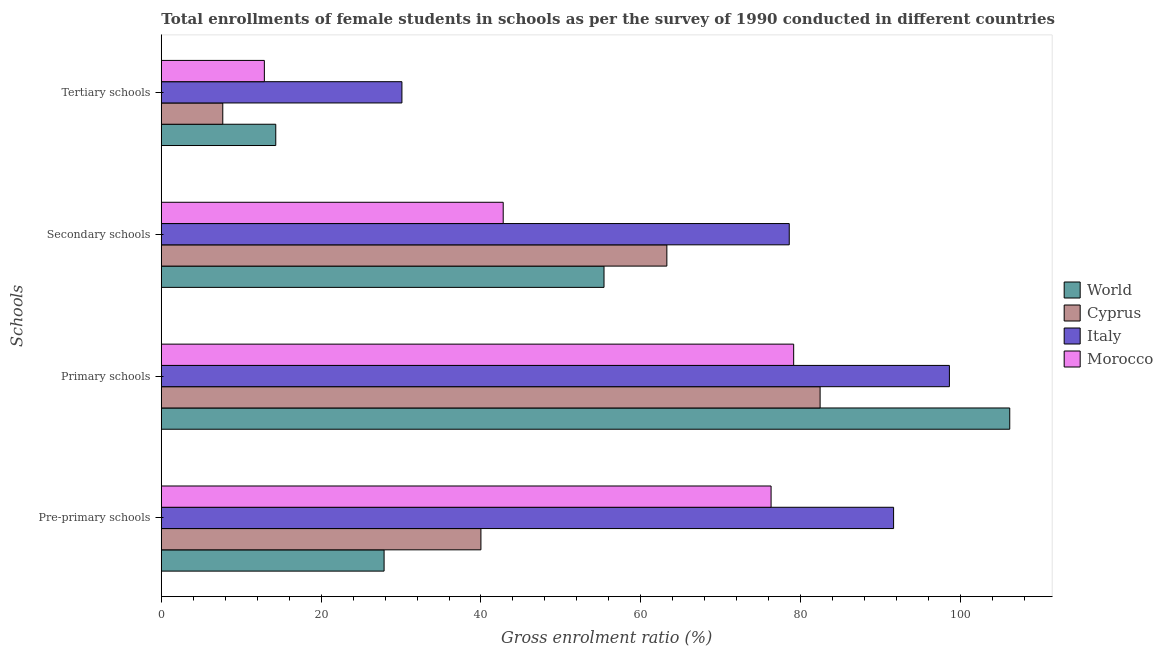How many groups of bars are there?
Offer a terse response. 4. Are the number of bars per tick equal to the number of legend labels?
Provide a short and direct response. Yes. How many bars are there on the 2nd tick from the top?
Offer a very short reply. 4. How many bars are there on the 3rd tick from the bottom?
Give a very brief answer. 4. What is the label of the 1st group of bars from the top?
Provide a short and direct response. Tertiary schools. What is the gross enrolment ratio(female) in pre-primary schools in Italy?
Give a very brief answer. 91.64. Across all countries, what is the maximum gross enrolment ratio(female) in secondary schools?
Provide a short and direct response. 78.58. Across all countries, what is the minimum gross enrolment ratio(female) in pre-primary schools?
Your answer should be very brief. 27.88. In which country was the gross enrolment ratio(female) in pre-primary schools maximum?
Provide a short and direct response. Italy. In which country was the gross enrolment ratio(female) in secondary schools minimum?
Offer a terse response. Morocco. What is the total gross enrolment ratio(female) in primary schools in the graph?
Your response must be concise. 366.37. What is the difference between the gross enrolment ratio(female) in secondary schools in World and that in Cyprus?
Provide a succinct answer. -7.87. What is the difference between the gross enrolment ratio(female) in secondary schools in Morocco and the gross enrolment ratio(female) in primary schools in Italy?
Offer a terse response. -55.84. What is the average gross enrolment ratio(female) in secondary schools per country?
Give a very brief answer. 60.01. What is the difference between the gross enrolment ratio(female) in secondary schools and gross enrolment ratio(female) in tertiary schools in Cyprus?
Provide a succinct answer. 55.57. What is the ratio of the gross enrolment ratio(female) in primary schools in Italy to that in World?
Keep it short and to the point. 0.93. What is the difference between the highest and the second highest gross enrolment ratio(female) in tertiary schools?
Your answer should be compact. 15.79. What is the difference between the highest and the lowest gross enrolment ratio(female) in tertiary schools?
Your response must be concise. 22.42. In how many countries, is the gross enrolment ratio(female) in pre-primary schools greater than the average gross enrolment ratio(female) in pre-primary schools taken over all countries?
Keep it short and to the point. 2. Is the sum of the gross enrolment ratio(female) in secondary schools in Italy and Cyprus greater than the maximum gross enrolment ratio(female) in primary schools across all countries?
Give a very brief answer. Yes. What does the 4th bar from the top in Secondary schools represents?
Your answer should be compact. World. What does the 3rd bar from the bottom in Secondary schools represents?
Your answer should be compact. Italy. How many bars are there?
Offer a very short reply. 16. Are all the bars in the graph horizontal?
Give a very brief answer. Yes. How many countries are there in the graph?
Ensure brevity in your answer.  4. What is the difference between two consecutive major ticks on the X-axis?
Make the answer very short. 20. Does the graph contain any zero values?
Your answer should be compact. No. Does the graph contain grids?
Offer a terse response. No. How many legend labels are there?
Ensure brevity in your answer.  4. What is the title of the graph?
Keep it short and to the point. Total enrollments of female students in schools as per the survey of 1990 conducted in different countries. Does "Cyprus" appear as one of the legend labels in the graph?
Your answer should be very brief. Yes. What is the label or title of the X-axis?
Your response must be concise. Gross enrolment ratio (%). What is the label or title of the Y-axis?
Offer a terse response. Schools. What is the Gross enrolment ratio (%) of World in Pre-primary schools?
Make the answer very short. 27.88. What is the Gross enrolment ratio (%) of Cyprus in Pre-primary schools?
Your answer should be compact. 40. What is the Gross enrolment ratio (%) in Italy in Pre-primary schools?
Make the answer very short. 91.64. What is the Gross enrolment ratio (%) of Morocco in Pre-primary schools?
Provide a succinct answer. 76.31. What is the Gross enrolment ratio (%) in World in Primary schools?
Offer a very short reply. 106.17. What is the Gross enrolment ratio (%) of Cyprus in Primary schools?
Keep it short and to the point. 82.44. What is the Gross enrolment ratio (%) in Italy in Primary schools?
Your answer should be very brief. 98.62. What is the Gross enrolment ratio (%) in Morocco in Primary schools?
Your answer should be compact. 79.13. What is the Gross enrolment ratio (%) of World in Secondary schools?
Your answer should be compact. 55.4. What is the Gross enrolment ratio (%) in Cyprus in Secondary schools?
Your answer should be compact. 63.26. What is the Gross enrolment ratio (%) in Italy in Secondary schools?
Provide a short and direct response. 78.58. What is the Gross enrolment ratio (%) of Morocco in Secondary schools?
Your response must be concise. 42.78. What is the Gross enrolment ratio (%) in World in Tertiary schools?
Offer a very short reply. 14.32. What is the Gross enrolment ratio (%) in Cyprus in Tertiary schools?
Provide a short and direct response. 7.69. What is the Gross enrolment ratio (%) in Italy in Tertiary schools?
Provide a short and direct response. 30.11. What is the Gross enrolment ratio (%) of Morocco in Tertiary schools?
Provide a short and direct response. 12.9. Across all Schools, what is the maximum Gross enrolment ratio (%) in World?
Offer a very short reply. 106.17. Across all Schools, what is the maximum Gross enrolment ratio (%) of Cyprus?
Your answer should be very brief. 82.44. Across all Schools, what is the maximum Gross enrolment ratio (%) of Italy?
Your answer should be very brief. 98.62. Across all Schools, what is the maximum Gross enrolment ratio (%) of Morocco?
Make the answer very short. 79.13. Across all Schools, what is the minimum Gross enrolment ratio (%) of World?
Offer a terse response. 14.32. Across all Schools, what is the minimum Gross enrolment ratio (%) of Cyprus?
Your answer should be compact. 7.69. Across all Schools, what is the minimum Gross enrolment ratio (%) of Italy?
Give a very brief answer. 30.11. Across all Schools, what is the minimum Gross enrolment ratio (%) in Morocco?
Your answer should be compact. 12.9. What is the total Gross enrolment ratio (%) of World in the graph?
Make the answer very short. 203.77. What is the total Gross enrolment ratio (%) of Cyprus in the graph?
Ensure brevity in your answer.  193.39. What is the total Gross enrolment ratio (%) in Italy in the graph?
Keep it short and to the point. 298.95. What is the total Gross enrolment ratio (%) in Morocco in the graph?
Keep it short and to the point. 211.12. What is the difference between the Gross enrolment ratio (%) of World in Pre-primary schools and that in Primary schools?
Your answer should be compact. -78.29. What is the difference between the Gross enrolment ratio (%) in Cyprus in Pre-primary schools and that in Primary schools?
Provide a short and direct response. -42.45. What is the difference between the Gross enrolment ratio (%) of Italy in Pre-primary schools and that in Primary schools?
Provide a short and direct response. -6.98. What is the difference between the Gross enrolment ratio (%) of Morocco in Pre-primary schools and that in Primary schools?
Make the answer very short. -2.83. What is the difference between the Gross enrolment ratio (%) of World in Pre-primary schools and that in Secondary schools?
Make the answer very short. -27.52. What is the difference between the Gross enrolment ratio (%) in Cyprus in Pre-primary schools and that in Secondary schools?
Provide a short and direct response. -23.27. What is the difference between the Gross enrolment ratio (%) of Italy in Pre-primary schools and that in Secondary schools?
Your response must be concise. 13.06. What is the difference between the Gross enrolment ratio (%) in Morocco in Pre-primary schools and that in Secondary schools?
Make the answer very short. 33.52. What is the difference between the Gross enrolment ratio (%) in World in Pre-primary schools and that in Tertiary schools?
Your answer should be very brief. 13.56. What is the difference between the Gross enrolment ratio (%) in Cyprus in Pre-primary schools and that in Tertiary schools?
Keep it short and to the point. 32.3. What is the difference between the Gross enrolment ratio (%) in Italy in Pre-primary schools and that in Tertiary schools?
Give a very brief answer. 61.53. What is the difference between the Gross enrolment ratio (%) in Morocco in Pre-primary schools and that in Tertiary schools?
Your answer should be compact. 63.41. What is the difference between the Gross enrolment ratio (%) in World in Primary schools and that in Secondary schools?
Ensure brevity in your answer.  50.77. What is the difference between the Gross enrolment ratio (%) of Cyprus in Primary schools and that in Secondary schools?
Your response must be concise. 19.18. What is the difference between the Gross enrolment ratio (%) of Italy in Primary schools and that in Secondary schools?
Offer a very short reply. 20.04. What is the difference between the Gross enrolment ratio (%) in Morocco in Primary schools and that in Secondary schools?
Offer a terse response. 36.35. What is the difference between the Gross enrolment ratio (%) of World in Primary schools and that in Tertiary schools?
Provide a succinct answer. 91.85. What is the difference between the Gross enrolment ratio (%) in Cyprus in Primary schools and that in Tertiary schools?
Offer a terse response. 74.75. What is the difference between the Gross enrolment ratio (%) of Italy in Primary schools and that in Tertiary schools?
Ensure brevity in your answer.  68.51. What is the difference between the Gross enrolment ratio (%) of Morocco in Primary schools and that in Tertiary schools?
Provide a short and direct response. 66.24. What is the difference between the Gross enrolment ratio (%) of World in Secondary schools and that in Tertiary schools?
Ensure brevity in your answer.  41.08. What is the difference between the Gross enrolment ratio (%) of Cyprus in Secondary schools and that in Tertiary schools?
Make the answer very short. 55.57. What is the difference between the Gross enrolment ratio (%) in Italy in Secondary schools and that in Tertiary schools?
Provide a short and direct response. 48.47. What is the difference between the Gross enrolment ratio (%) in Morocco in Secondary schools and that in Tertiary schools?
Offer a terse response. 29.89. What is the difference between the Gross enrolment ratio (%) of World in Pre-primary schools and the Gross enrolment ratio (%) of Cyprus in Primary schools?
Ensure brevity in your answer.  -54.56. What is the difference between the Gross enrolment ratio (%) in World in Pre-primary schools and the Gross enrolment ratio (%) in Italy in Primary schools?
Your answer should be very brief. -70.74. What is the difference between the Gross enrolment ratio (%) in World in Pre-primary schools and the Gross enrolment ratio (%) in Morocco in Primary schools?
Make the answer very short. -51.25. What is the difference between the Gross enrolment ratio (%) of Cyprus in Pre-primary schools and the Gross enrolment ratio (%) of Italy in Primary schools?
Your answer should be compact. -58.62. What is the difference between the Gross enrolment ratio (%) in Cyprus in Pre-primary schools and the Gross enrolment ratio (%) in Morocco in Primary schools?
Your answer should be compact. -39.14. What is the difference between the Gross enrolment ratio (%) of Italy in Pre-primary schools and the Gross enrolment ratio (%) of Morocco in Primary schools?
Offer a very short reply. 12.5. What is the difference between the Gross enrolment ratio (%) in World in Pre-primary schools and the Gross enrolment ratio (%) in Cyprus in Secondary schools?
Provide a short and direct response. -35.39. What is the difference between the Gross enrolment ratio (%) in World in Pre-primary schools and the Gross enrolment ratio (%) in Italy in Secondary schools?
Give a very brief answer. -50.7. What is the difference between the Gross enrolment ratio (%) of World in Pre-primary schools and the Gross enrolment ratio (%) of Morocco in Secondary schools?
Your response must be concise. -14.9. What is the difference between the Gross enrolment ratio (%) of Cyprus in Pre-primary schools and the Gross enrolment ratio (%) of Italy in Secondary schools?
Provide a succinct answer. -38.58. What is the difference between the Gross enrolment ratio (%) in Cyprus in Pre-primary schools and the Gross enrolment ratio (%) in Morocco in Secondary schools?
Provide a short and direct response. -2.79. What is the difference between the Gross enrolment ratio (%) of Italy in Pre-primary schools and the Gross enrolment ratio (%) of Morocco in Secondary schools?
Your response must be concise. 48.85. What is the difference between the Gross enrolment ratio (%) in World in Pre-primary schools and the Gross enrolment ratio (%) in Cyprus in Tertiary schools?
Ensure brevity in your answer.  20.19. What is the difference between the Gross enrolment ratio (%) of World in Pre-primary schools and the Gross enrolment ratio (%) of Italy in Tertiary schools?
Offer a very short reply. -2.23. What is the difference between the Gross enrolment ratio (%) in World in Pre-primary schools and the Gross enrolment ratio (%) in Morocco in Tertiary schools?
Offer a terse response. 14.98. What is the difference between the Gross enrolment ratio (%) of Cyprus in Pre-primary schools and the Gross enrolment ratio (%) of Italy in Tertiary schools?
Ensure brevity in your answer.  9.89. What is the difference between the Gross enrolment ratio (%) of Cyprus in Pre-primary schools and the Gross enrolment ratio (%) of Morocco in Tertiary schools?
Your answer should be compact. 27.1. What is the difference between the Gross enrolment ratio (%) of Italy in Pre-primary schools and the Gross enrolment ratio (%) of Morocco in Tertiary schools?
Provide a short and direct response. 78.74. What is the difference between the Gross enrolment ratio (%) in World in Primary schools and the Gross enrolment ratio (%) in Cyprus in Secondary schools?
Your response must be concise. 42.91. What is the difference between the Gross enrolment ratio (%) in World in Primary schools and the Gross enrolment ratio (%) in Italy in Secondary schools?
Offer a terse response. 27.59. What is the difference between the Gross enrolment ratio (%) of World in Primary schools and the Gross enrolment ratio (%) of Morocco in Secondary schools?
Offer a terse response. 63.39. What is the difference between the Gross enrolment ratio (%) in Cyprus in Primary schools and the Gross enrolment ratio (%) in Italy in Secondary schools?
Keep it short and to the point. 3.86. What is the difference between the Gross enrolment ratio (%) in Cyprus in Primary schools and the Gross enrolment ratio (%) in Morocco in Secondary schools?
Your answer should be very brief. 39.66. What is the difference between the Gross enrolment ratio (%) in Italy in Primary schools and the Gross enrolment ratio (%) in Morocco in Secondary schools?
Provide a short and direct response. 55.84. What is the difference between the Gross enrolment ratio (%) of World in Primary schools and the Gross enrolment ratio (%) of Cyprus in Tertiary schools?
Provide a short and direct response. 98.48. What is the difference between the Gross enrolment ratio (%) in World in Primary schools and the Gross enrolment ratio (%) in Italy in Tertiary schools?
Provide a short and direct response. 76.06. What is the difference between the Gross enrolment ratio (%) in World in Primary schools and the Gross enrolment ratio (%) in Morocco in Tertiary schools?
Offer a terse response. 93.28. What is the difference between the Gross enrolment ratio (%) of Cyprus in Primary schools and the Gross enrolment ratio (%) of Italy in Tertiary schools?
Your response must be concise. 52.33. What is the difference between the Gross enrolment ratio (%) of Cyprus in Primary schools and the Gross enrolment ratio (%) of Morocco in Tertiary schools?
Give a very brief answer. 69.55. What is the difference between the Gross enrolment ratio (%) of Italy in Primary schools and the Gross enrolment ratio (%) of Morocco in Tertiary schools?
Your answer should be compact. 85.73. What is the difference between the Gross enrolment ratio (%) of World in Secondary schools and the Gross enrolment ratio (%) of Cyprus in Tertiary schools?
Your answer should be very brief. 47.71. What is the difference between the Gross enrolment ratio (%) of World in Secondary schools and the Gross enrolment ratio (%) of Italy in Tertiary schools?
Your answer should be compact. 25.29. What is the difference between the Gross enrolment ratio (%) in World in Secondary schools and the Gross enrolment ratio (%) in Morocco in Tertiary schools?
Ensure brevity in your answer.  42.5. What is the difference between the Gross enrolment ratio (%) of Cyprus in Secondary schools and the Gross enrolment ratio (%) of Italy in Tertiary schools?
Offer a very short reply. 33.15. What is the difference between the Gross enrolment ratio (%) in Cyprus in Secondary schools and the Gross enrolment ratio (%) in Morocco in Tertiary schools?
Offer a very short reply. 50.37. What is the difference between the Gross enrolment ratio (%) of Italy in Secondary schools and the Gross enrolment ratio (%) of Morocco in Tertiary schools?
Ensure brevity in your answer.  65.68. What is the average Gross enrolment ratio (%) of World per Schools?
Make the answer very short. 50.94. What is the average Gross enrolment ratio (%) of Cyprus per Schools?
Give a very brief answer. 48.35. What is the average Gross enrolment ratio (%) of Italy per Schools?
Ensure brevity in your answer.  74.74. What is the average Gross enrolment ratio (%) of Morocco per Schools?
Give a very brief answer. 52.78. What is the difference between the Gross enrolment ratio (%) of World and Gross enrolment ratio (%) of Cyprus in Pre-primary schools?
Give a very brief answer. -12.12. What is the difference between the Gross enrolment ratio (%) in World and Gross enrolment ratio (%) in Italy in Pre-primary schools?
Give a very brief answer. -63.76. What is the difference between the Gross enrolment ratio (%) in World and Gross enrolment ratio (%) in Morocco in Pre-primary schools?
Offer a very short reply. -48.43. What is the difference between the Gross enrolment ratio (%) in Cyprus and Gross enrolment ratio (%) in Italy in Pre-primary schools?
Provide a short and direct response. -51.64. What is the difference between the Gross enrolment ratio (%) in Cyprus and Gross enrolment ratio (%) in Morocco in Pre-primary schools?
Provide a succinct answer. -36.31. What is the difference between the Gross enrolment ratio (%) in Italy and Gross enrolment ratio (%) in Morocco in Pre-primary schools?
Offer a very short reply. 15.33. What is the difference between the Gross enrolment ratio (%) in World and Gross enrolment ratio (%) in Cyprus in Primary schools?
Your response must be concise. 23.73. What is the difference between the Gross enrolment ratio (%) in World and Gross enrolment ratio (%) in Italy in Primary schools?
Offer a terse response. 7.55. What is the difference between the Gross enrolment ratio (%) of World and Gross enrolment ratio (%) of Morocco in Primary schools?
Provide a short and direct response. 27.04. What is the difference between the Gross enrolment ratio (%) in Cyprus and Gross enrolment ratio (%) in Italy in Primary schools?
Your answer should be very brief. -16.18. What is the difference between the Gross enrolment ratio (%) in Cyprus and Gross enrolment ratio (%) in Morocco in Primary schools?
Your response must be concise. 3.31. What is the difference between the Gross enrolment ratio (%) in Italy and Gross enrolment ratio (%) in Morocco in Primary schools?
Your answer should be compact. 19.49. What is the difference between the Gross enrolment ratio (%) of World and Gross enrolment ratio (%) of Cyprus in Secondary schools?
Your response must be concise. -7.87. What is the difference between the Gross enrolment ratio (%) in World and Gross enrolment ratio (%) in Italy in Secondary schools?
Your answer should be compact. -23.18. What is the difference between the Gross enrolment ratio (%) in World and Gross enrolment ratio (%) in Morocco in Secondary schools?
Your response must be concise. 12.62. What is the difference between the Gross enrolment ratio (%) of Cyprus and Gross enrolment ratio (%) of Italy in Secondary schools?
Your response must be concise. -15.32. What is the difference between the Gross enrolment ratio (%) in Cyprus and Gross enrolment ratio (%) in Morocco in Secondary schools?
Offer a terse response. 20.48. What is the difference between the Gross enrolment ratio (%) in Italy and Gross enrolment ratio (%) in Morocco in Secondary schools?
Ensure brevity in your answer.  35.8. What is the difference between the Gross enrolment ratio (%) of World and Gross enrolment ratio (%) of Cyprus in Tertiary schools?
Give a very brief answer. 6.63. What is the difference between the Gross enrolment ratio (%) of World and Gross enrolment ratio (%) of Italy in Tertiary schools?
Provide a succinct answer. -15.79. What is the difference between the Gross enrolment ratio (%) in World and Gross enrolment ratio (%) in Morocco in Tertiary schools?
Your response must be concise. 1.43. What is the difference between the Gross enrolment ratio (%) in Cyprus and Gross enrolment ratio (%) in Italy in Tertiary schools?
Your answer should be compact. -22.42. What is the difference between the Gross enrolment ratio (%) of Cyprus and Gross enrolment ratio (%) of Morocco in Tertiary schools?
Provide a succinct answer. -5.2. What is the difference between the Gross enrolment ratio (%) in Italy and Gross enrolment ratio (%) in Morocco in Tertiary schools?
Provide a succinct answer. 17.21. What is the ratio of the Gross enrolment ratio (%) in World in Pre-primary schools to that in Primary schools?
Offer a very short reply. 0.26. What is the ratio of the Gross enrolment ratio (%) in Cyprus in Pre-primary schools to that in Primary schools?
Your answer should be compact. 0.49. What is the ratio of the Gross enrolment ratio (%) in Italy in Pre-primary schools to that in Primary schools?
Ensure brevity in your answer.  0.93. What is the ratio of the Gross enrolment ratio (%) of Morocco in Pre-primary schools to that in Primary schools?
Make the answer very short. 0.96. What is the ratio of the Gross enrolment ratio (%) in World in Pre-primary schools to that in Secondary schools?
Provide a short and direct response. 0.5. What is the ratio of the Gross enrolment ratio (%) of Cyprus in Pre-primary schools to that in Secondary schools?
Ensure brevity in your answer.  0.63. What is the ratio of the Gross enrolment ratio (%) of Italy in Pre-primary schools to that in Secondary schools?
Offer a very short reply. 1.17. What is the ratio of the Gross enrolment ratio (%) of Morocco in Pre-primary schools to that in Secondary schools?
Keep it short and to the point. 1.78. What is the ratio of the Gross enrolment ratio (%) in World in Pre-primary schools to that in Tertiary schools?
Make the answer very short. 1.95. What is the ratio of the Gross enrolment ratio (%) in Cyprus in Pre-primary schools to that in Tertiary schools?
Offer a terse response. 5.2. What is the ratio of the Gross enrolment ratio (%) of Italy in Pre-primary schools to that in Tertiary schools?
Your answer should be very brief. 3.04. What is the ratio of the Gross enrolment ratio (%) of Morocco in Pre-primary schools to that in Tertiary schools?
Keep it short and to the point. 5.92. What is the ratio of the Gross enrolment ratio (%) of World in Primary schools to that in Secondary schools?
Give a very brief answer. 1.92. What is the ratio of the Gross enrolment ratio (%) of Cyprus in Primary schools to that in Secondary schools?
Keep it short and to the point. 1.3. What is the ratio of the Gross enrolment ratio (%) of Italy in Primary schools to that in Secondary schools?
Ensure brevity in your answer.  1.25. What is the ratio of the Gross enrolment ratio (%) in Morocco in Primary schools to that in Secondary schools?
Your response must be concise. 1.85. What is the ratio of the Gross enrolment ratio (%) in World in Primary schools to that in Tertiary schools?
Provide a short and direct response. 7.41. What is the ratio of the Gross enrolment ratio (%) in Cyprus in Primary schools to that in Tertiary schools?
Make the answer very short. 10.72. What is the ratio of the Gross enrolment ratio (%) in Italy in Primary schools to that in Tertiary schools?
Make the answer very short. 3.28. What is the ratio of the Gross enrolment ratio (%) of Morocco in Primary schools to that in Tertiary schools?
Your answer should be very brief. 6.14. What is the ratio of the Gross enrolment ratio (%) of World in Secondary schools to that in Tertiary schools?
Offer a very short reply. 3.87. What is the ratio of the Gross enrolment ratio (%) of Cyprus in Secondary schools to that in Tertiary schools?
Give a very brief answer. 8.22. What is the ratio of the Gross enrolment ratio (%) of Italy in Secondary schools to that in Tertiary schools?
Your answer should be compact. 2.61. What is the ratio of the Gross enrolment ratio (%) of Morocco in Secondary schools to that in Tertiary schools?
Offer a very short reply. 3.32. What is the difference between the highest and the second highest Gross enrolment ratio (%) of World?
Make the answer very short. 50.77. What is the difference between the highest and the second highest Gross enrolment ratio (%) in Cyprus?
Offer a terse response. 19.18. What is the difference between the highest and the second highest Gross enrolment ratio (%) in Italy?
Your answer should be very brief. 6.98. What is the difference between the highest and the second highest Gross enrolment ratio (%) in Morocco?
Ensure brevity in your answer.  2.83. What is the difference between the highest and the lowest Gross enrolment ratio (%) of World?
Ensure brevity in your answer.  91.85. What is the difference between the highest and the lowest Gross enrolment ratio (%) in Cyprus?
Your answer should be compact. 74.75. What is the difference between the highest and the lowest Gross enrolment ratio (%) in Italy?
Provide a succinct answer. 68.51. What is the difference between the highest and the lowest Gross enrolment ratio (%) in Morocco?
Give a very brief answer. 66.24. 